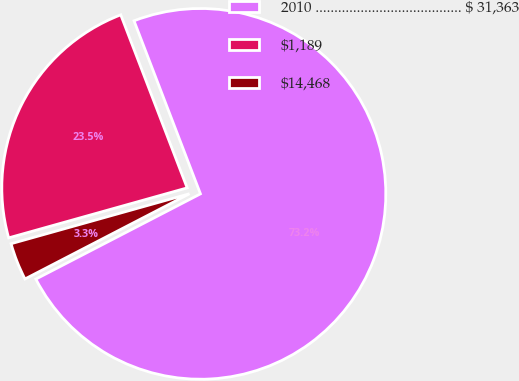Convert chart to OTSL. <chart><loc_0><loc_0><loc_500><loc_500><pie_chart><fcel>2010 ....................................... $ 31,363<fcel>$1,189<fcel>$14,468<nl><fcel>73.22%<fcel>23.51%<fcel>3.26%<nl></chart> 